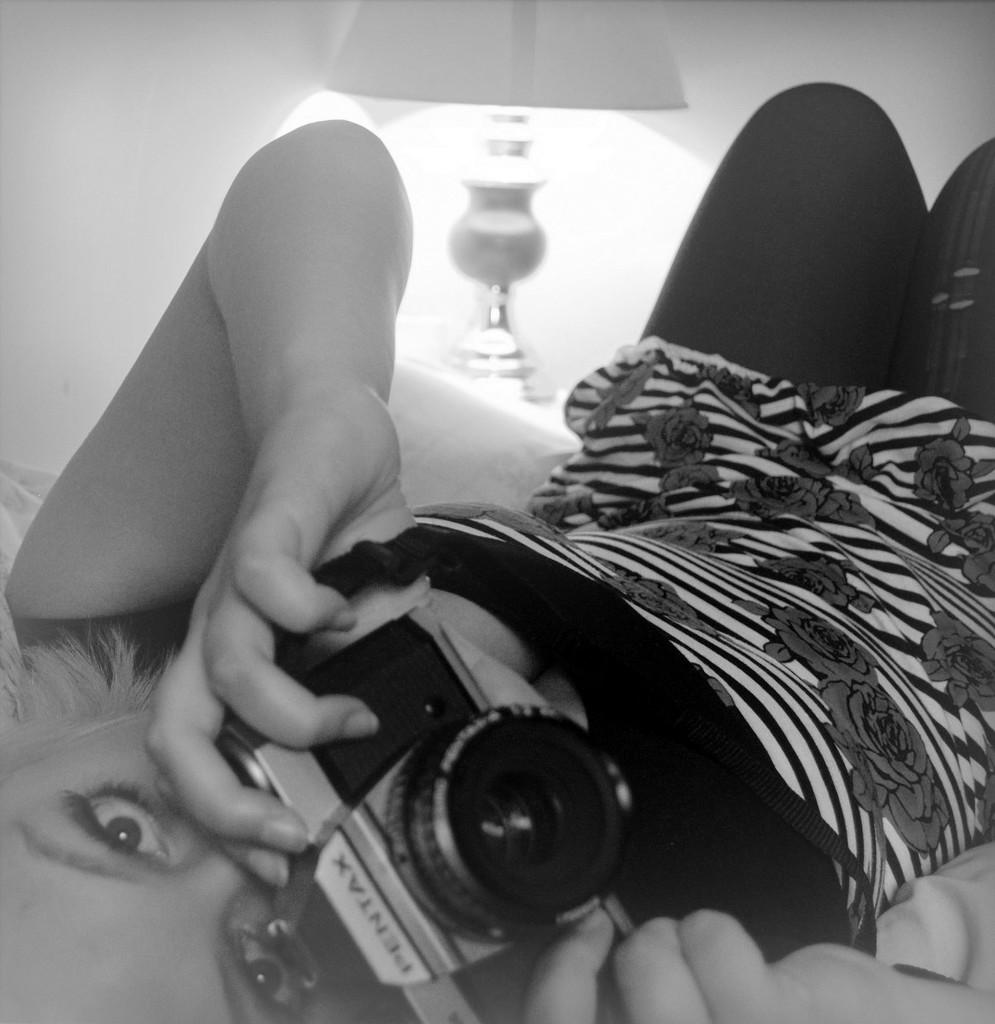Who is the main subject in the image? There is a woman in the image. What is the woman doing in the image? The woman is lying down. What object is the woman holding in the image? The woman is holding a camera. What can be seen in the background of the image? There is a lamp in the background of the image. What year is depicted in the image? The image does not depict a specific year; it is a photograph of a woman lying down and holding a camera. How many people are in the group in the image? There is no group present in the image; it features a single woman. 